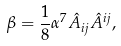<formula> <loc_0><loc_0><loc_500><loc_500>\beta = \frac { 1 } { 8 } \alpha ^ { 7 } \hat { A } _ { i j } \hat { A } ^ { i j } ,</formula> 